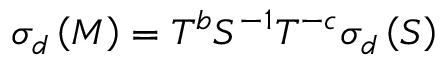Convert formula to latex. <formula><loc_0><loc_0><loc_500><loc_500>\sigma _ { d } \left ( M \right ) = T ^ { b } S ^ { - 1 } T ^ { - c } \sigma _ { d } \left ( S \right )</formula> 